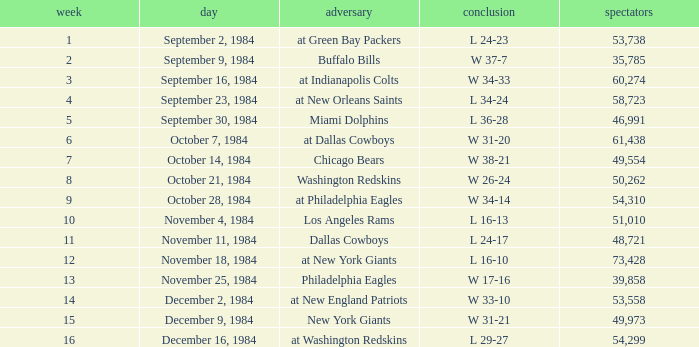What was the result in a week lower than 10 with an opponent of Chicago Bears? W 38-21. 